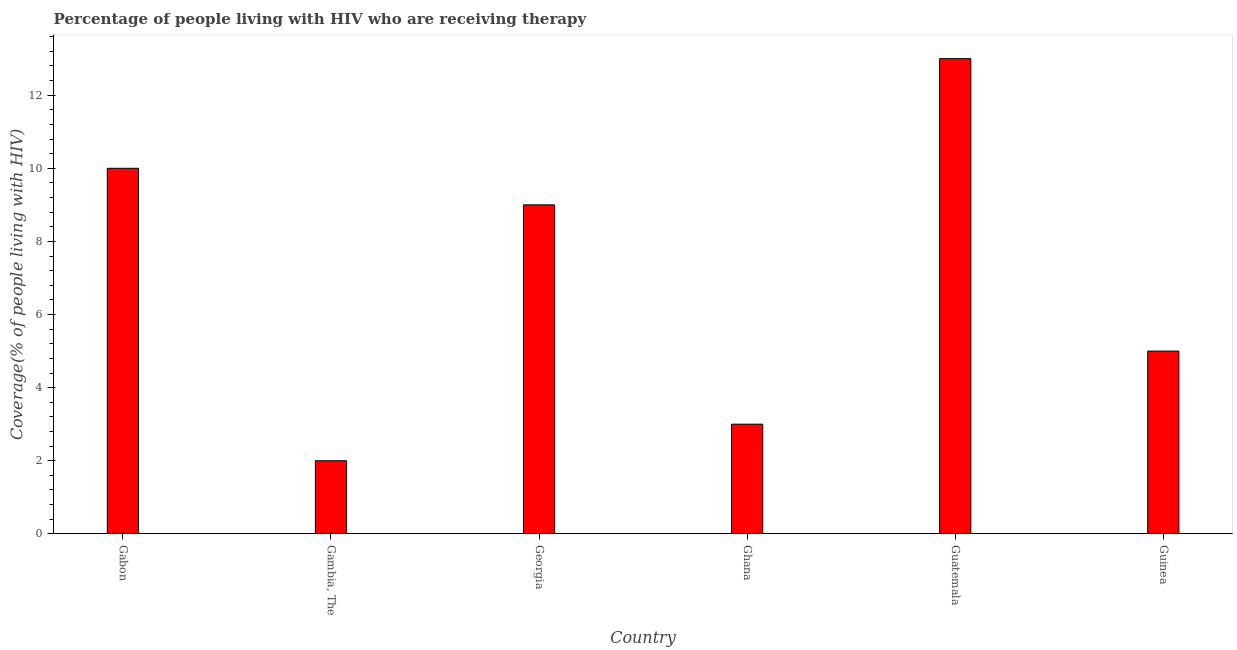Does the graph contain any zero values?
Offer a very short reply. No. What is the title of the graph?
Offer a very short reply. Percentage of people living with HIV who are receiving therapy. What is the label or title of the Y-axis?
Provide a succinct answer. Coverage(% of people living with HIV). What is the antiretroviral therapy coverage in Gambia, The?
Offer a terse response. 2. Across all countries, what is the maximum antiretroviral therapy coverage?
Your answer should be compact. 13. Across all countries, what is the minimum antiretroviral therapy coverage?
Your response must be concise. 2. In which country was the antiretroviral therapy coverage maximum?
Give a very brief answer. Guatemala. In which country was the antiretroviral therapy coverage minimum?
Provide a succinct answer. Gambia, The. What is the difference between the antiretroviral therapy coverage in Gambia, The and Guinea?
Provide a short and direct response. -3. What is the median antiretroviral therapy coverage?
Provide a short and direct response. 7. In how many countries, is the antiretroviral therapy coverage greater than 9.2 %?
Make the answer very short. 2. Is the antiretroviral therapy coverage in Georgia less than that in Guinea?
Provide a succinct answer. No. Is the difference between the antiretroviral therapy coverage in Gabon and Gambia, The greater than the difference between any two countries?
Ensure brevity in your answer.  No. What is the difference between the highest and the second highest antiretroviral therapy coverage?
Make the answer very short. 3. How many bars are there?
Your answer should be very brief. 6. How many countries are there in the graph?
Ensure brevity in your answer.  6. What is the difference between two consecutive major ticks on the Y-axis?
Make the answer very short. 2. What is the Coverage(% of people living with HIV) in Gabon?
Offer a terse response. 10. What is the Coverage(% of people living with HIV) in Gambia, The?
Offer a very short reply. 2. What is the Coverage(% of people living with HIV) in Guatemala?
Give a very brief answer. 13. What is the Coverage(% of people living with HIV) of Guinea?
Your answer should be very brief. 5. What is the difference between the Coverage(% of people living with HIV) in Gabon and Ghana?
Your answer should be very brief. 7. What is the difference between the Coverage(% of people living with HIV) in Gabon and Guinea?
Keep it short and to the point. 5. What is the difference between the Coverage(% of people living with HIV) in Gambia, The and Guatemala?
Your answer should be very brief. -11. What is the difference between the Coverage(% of people living with HIV) in Gambia, The and Guinea?
Give a very brief answer. -3. What is the difference between the Coverage(% of people living with HIV) in Georgia and Ghana?
Ensure brevity in your answer.  6. What is the difference between the Coverage(% of people living with HIV) in Ghana and Guinea?
Keep it short and to the point. -2. What is the difference between the Coverage(% of people living with HIV) in Guatemala and Guinea?
Ensure brevity in your answer.  8. What is the ratio of the Coverage(% of people living with HIV) in Gabon to that in Gambia, The?
Offer a very short reply. 5. What is the ratio of the Coverage(% of people living with HIV) in Gabon to that in Georgia?
Ensure brevity in your answer.  1.11. What is the ratio of the Coverage(% of people living with HIV) in Gabon to that in Ghana?
Provide a succinct answer. 3.33. What is the ratio of the Coverage(% of people living with HIV) in Gabon to that in Guatemala?
Provide a succinct answer. 0.77. What is the ratio of the Coverage(% of people living with HIV) in Gambia, The to that in Georgia?
Keep it short and to the point. 0.22. What is the ratio of the Coverage(% of people living with HIV) in Gambia, The to that in Ghana?
Your response must be concise. 0.67. What is the ratio of the Coverage(% of people living with HIV) in Gambia, The to that in Guatemala?
Ensure brevity in your answer.  0.15. What is the ratio of the Coverage(% of people living with HIV) in Gambia, The to that in Guinea?
Offer a very short reply. 0.4. What is the ratio of the Coverage(% of people living with HIV) in Georgia to that in Guatemala?
Offer a terse response. 0.69. What is the ratio of the Coverage(% of people living with HIV) in Ghana to that in Guatemala?
Keep it short and to the point. 0.23. What is the ratio of the Coverage(% of people living with HIV) in Guatemala to that in Guinea?
Provide a short and direct response. 2.6. 